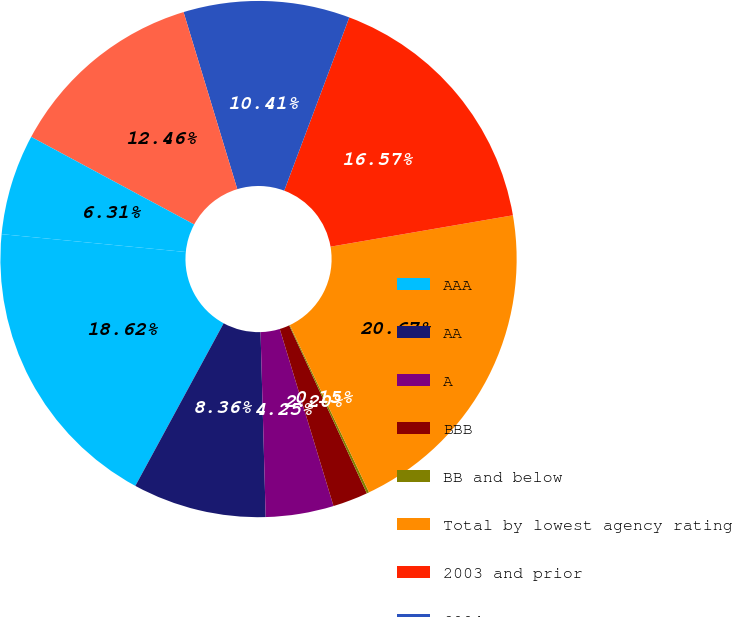<chart> <loc_0><loc_0><loc_500><loc_500><pie_chart><fcel>AAA<fcel>AA<fcel>A<fcel>BBB<fcel>BB and below<fcel>Total by lowest agency rating<fcel>2003 and prior<fcel>2004<fcel>2005<fcel>2006 (1)<nl><fcel>18.62%<fcel>8.36%<fcel>4.25%<fcel>2.2%<fcel>0.15%<fcel>20.67%<fcel>16.57%<fcel>10.41%<fcel>12.46%<fcel>6.31%<nl></chart> 